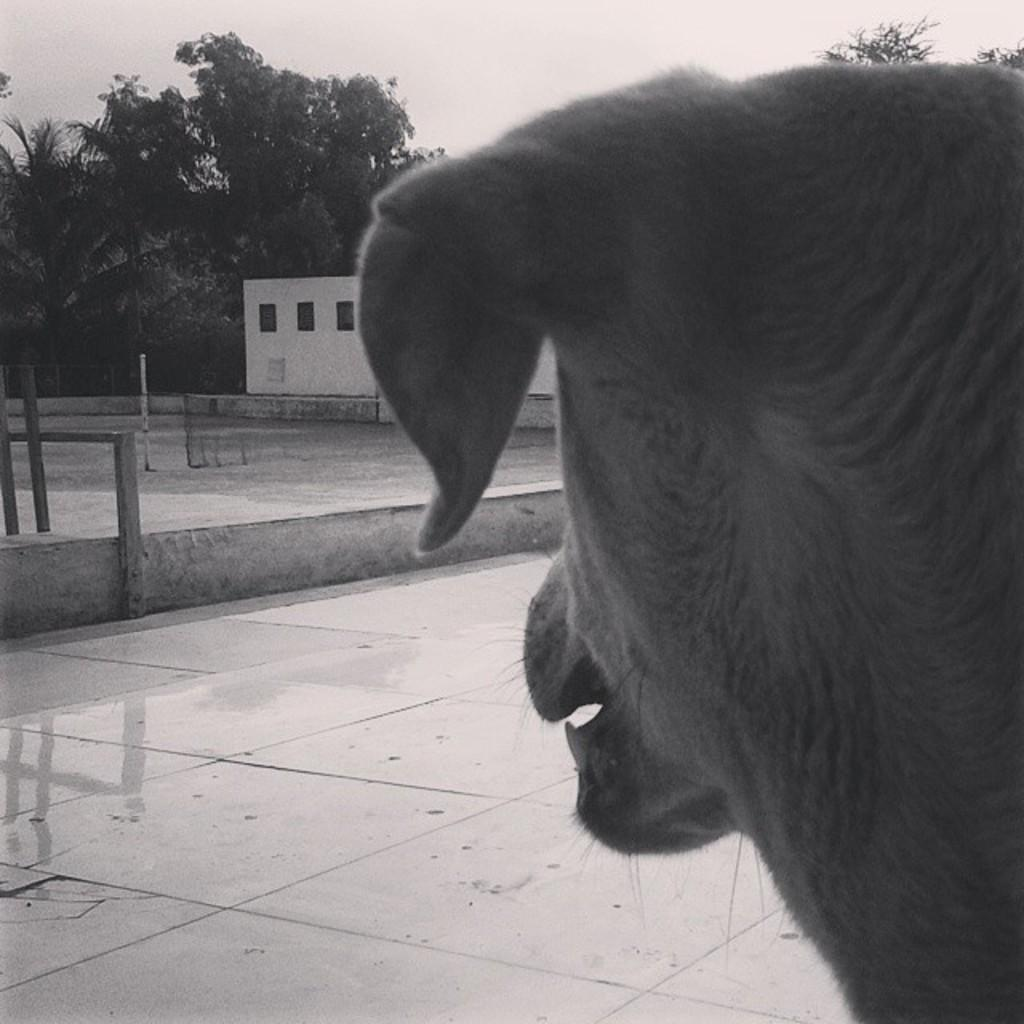What is on the road in the image? There is an animal on the road in the image. What structure is in front of the animal in the image? There is a house in front of the animal in the image. What type of natural environment is depicted in the image? There are many trees in the image, indicating a wooded or forested area. What is the color scheme of the image? The image is black and white. What type of pencil is the animal holding in the image? There is no pencil present in the image, and the animal is not holding anything. What holiday is being celebrated in the image? There is no indication of a holiday being celebrated in the image. What government agency is responsible for the animal's presence on the road in the image? There is no information about a government agency or any human intervention in the image. 